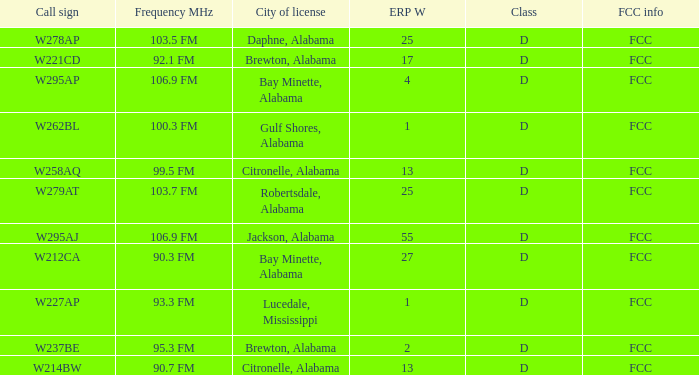Name the call sign for ERP W of 4 W295AP. 